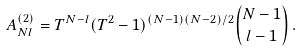<formula> <loc_0><loc_0><loc_500><loc_500>A _ { N l } ^ { ( 2 ) } = T ^ { N - l } ( T ^ { 2 } - 1 ) ^ { ( N - 1 ) ( N - 2 ) / 2 } { N - 1 \choose l - 1 } \, .</formula> 